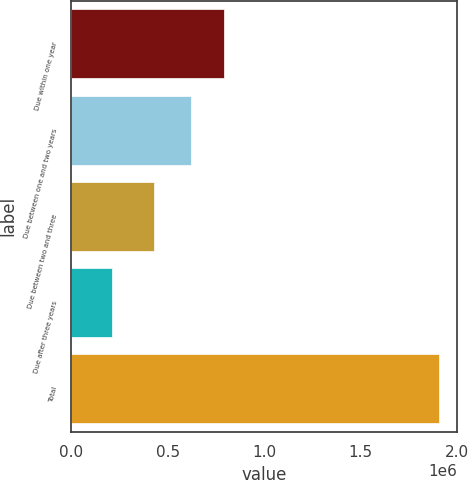<chart> <loc_0><loc_0><loc_500><loc_500><bar_chart><fcel>Due within one year<fcel>Due between one and two years<fcel>Due between two and three<fcel>Due after three years<fcel>Total<nl><fcel>788967<fcel>619557<fcel>427913<fcel>210802<fcel>1.9049e+06<nl></chart> 